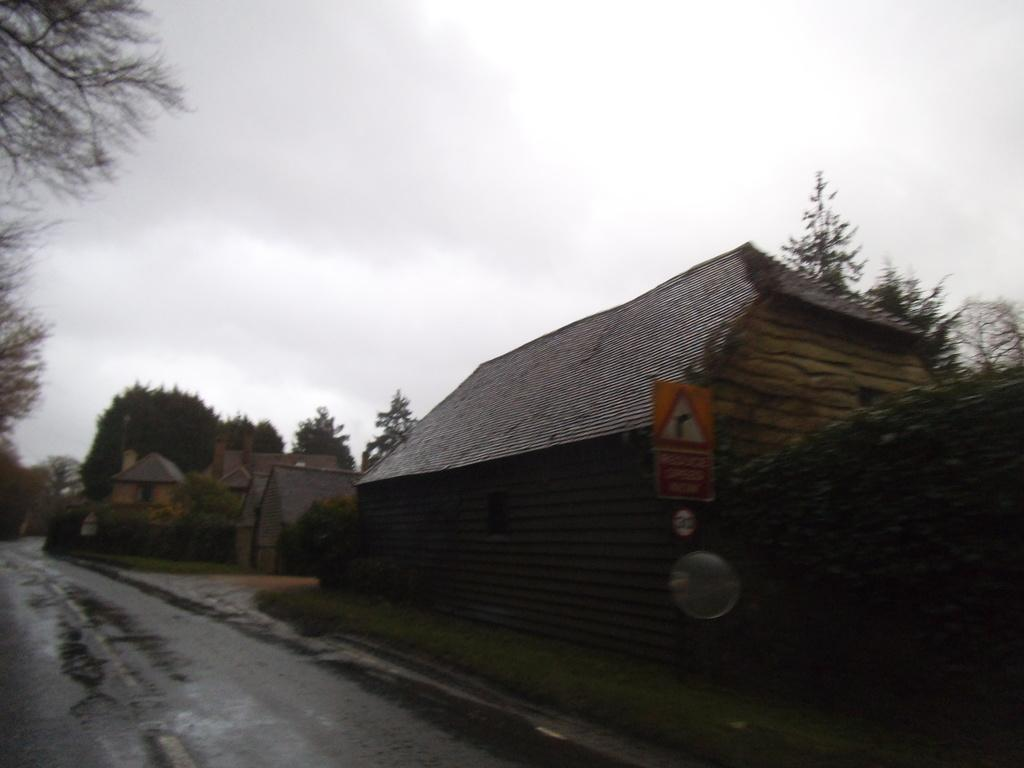What type of structures are located on the right side of the image? There are houses on the right side of the image. What else can be seen on the right side of the image besides the houses? There are trees on the right side of the image. What type of vegetation is present on the left side of the image? There are trees on the left side of the image. What is in the middle of the trees in the image? There is a road in the middle of the trees. What is visible in the background of the image? The sky is visible in the background of the image. What type of punishment is being handed out to the bean in the image? There is no bean or punishment present in the image. What type of map is visible in the image? There is no map present in the image. 